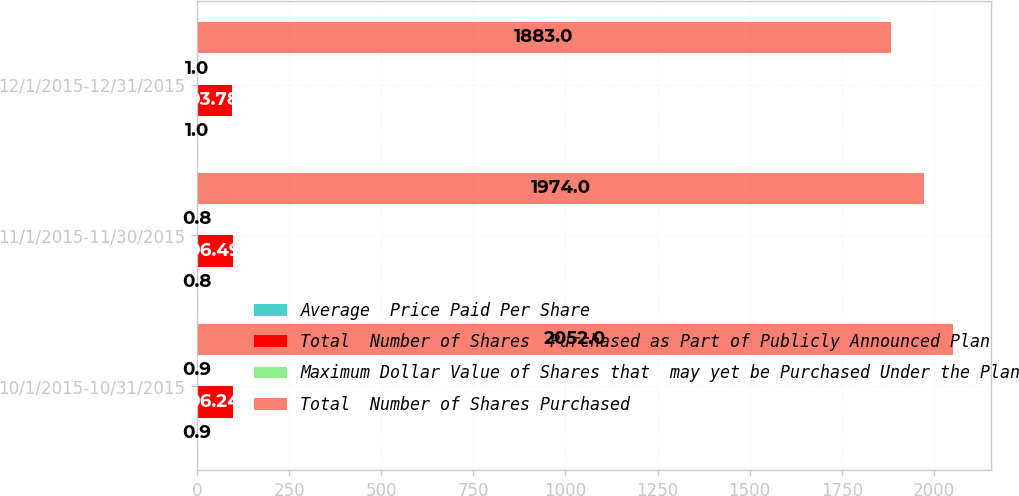Convert chart to OTSL. <chart><loc_0><loc_0><loc_500><loc_500><stacked_bar_chart><ecel><fcel>10/1/2015-10/31/2015<fcel>11/1/2015-11/30/2015<fcel>12/1/2015-12/31/2015<nl><fcel>Average  Price Paid Per Share<fcel>0.9<fcel>0.8<fcel>1<nl><fcel>Total  Number of Shares  Purchased as Part of Publicly Announced Plan<fcel>96.24<fcel>96.49<fcel>93.78<nl><fcel>Maximum Dollar Value of Shares that  may yet be Purchased Under the Plan<fcel>0.9<fcel>0.8<fcel>1<nl><fcel>Total  Number of Shares Purchased<fcel>2052<fcel>1974<fcel>1883<nl></chart> 